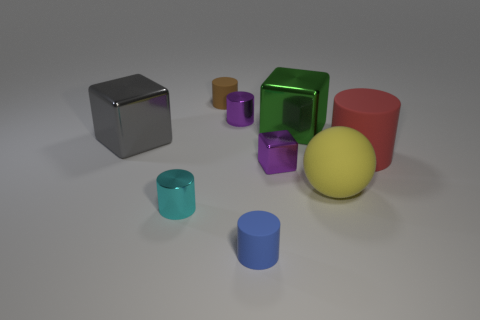How many tiny brown cylinders are made of the same material as the sphere?
Offer a terse response. 1. Are there fewer rubber cylinders that are in front of the brown cylinder than spheres?
Offer a terse response. No. There is a cube to the right of the tiny metal thing that is to the right of the tiny blue rubber object; what size is it?
Provide a short and direct response. Large. There is a tiny shiny cube; does it have the same color as the metal cylinder behind the gray cube?
Give a very brief answer. Yes. What is the material of the purple cylinder that is the same size as the cyan metallic cylinder?
Your response must be concise. Metal. Are there fewer big spheres in front of the blue rubber thing than small blue things that are on the left side of the big green thing?
Provide a short and direct response. Yes. There is a matte object behind the block that is on the left side of the small cyan cylinder; what shape is it?
Provide a short and direct response. Cylinder. Are there any yellow shiny things?
Offer a terse response. No. What color is the rubber cylinder on the right side of the blue cylinder?
Ensure brevity in your answer.  Red. Are there any large yellow matte balls to the left of the purple cube?
Provide a short and direct response. No. 